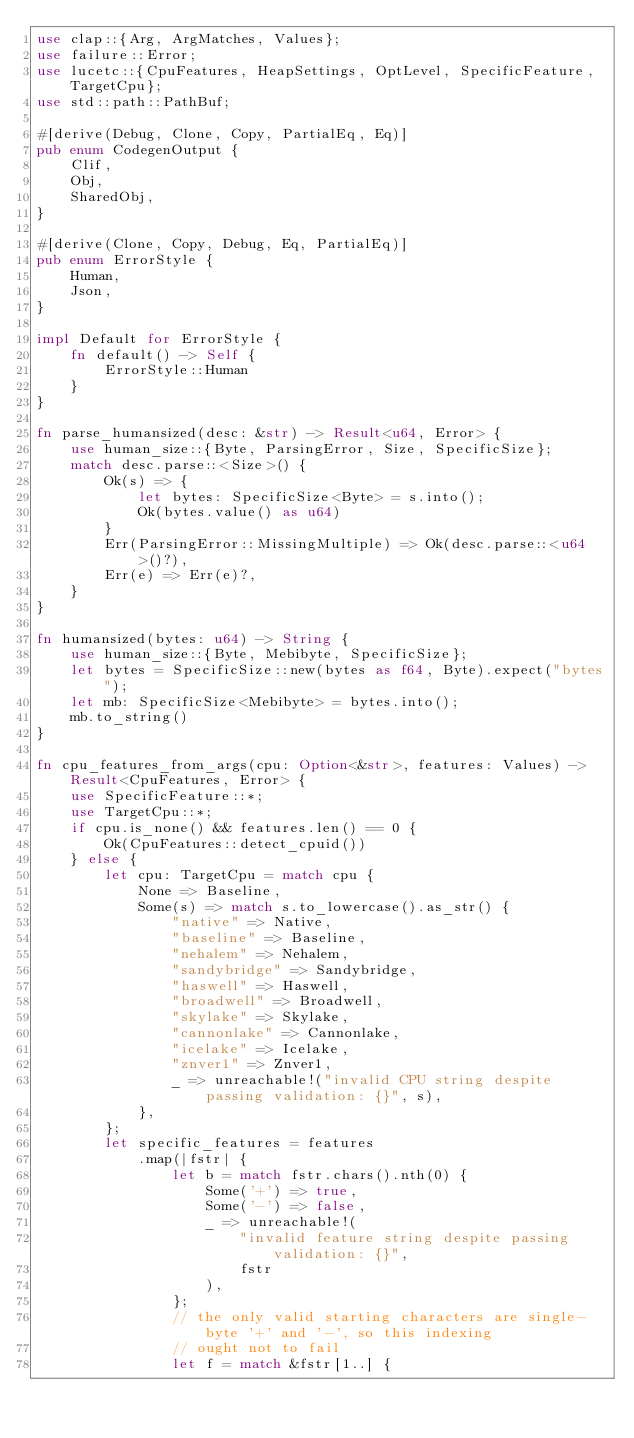Convert code to text. <code><loc_0><loc_0><loc_500><loc_500><_Rust_>use clap::{Arg, ArgMatches, Values};
use failure::Error;
use lucetc::{CpuFeatures, HeapSettings, OptLevel, SpecificFeature, TargetCpu};
use std::path::PathBuf;

#[derive(Debug, Clone, Copy, PartialEq, Eq)]
pub enum CodegenOutput {
    Clif,
    Obj,
    SharedObj,
}

#[derive(Clone, Copy, Debug, Eq, PartialEq)]
pub enum ErrorStyle {
    Human,
    Json,
}

impl Default for ErrorStyle {
    fn default() -> Self {
        ErrorStyle::Human
    }
}

fn parse_humansized(desc: &str) -> Result<u64, Error> {
    use human_size::{Byte, ParsingError, Size, SpecificSize};
    match desc.parse::<Size>() {
        Ok(s) => {
            let bytes: SpecificSize<Byte> = s.into();
            Ok(bytes.value() as u64)
        }
        Err(ParsingError::MissingMultiple) => Ok(desc.parse::<u64>()?),
        Err(e) => Err(e)?,
    }
}

fn humansized(bytes: u64) -> String {
    use human_size::{Byte, Mebibyte, SpecificSize};
    let bytes = SpecificSize::new(bytes as f64, Byte).expect("bytes");
    let mb: SpecificSize<Mebibyte> = bytes.into();
    mb.to_string()
}

fn cpu_features_from_args(cpu: Option<&str>, features: Values) -> Result<CpuFeatures, Error> {
    use SpecificFeature::*;
    use TargetCpu::*;
    if cpu.is_none() && features.len() == 0 {
        Ok(CpuFeatures::detect_cpuid())
    } else {
        let cpu: TargetCpu = match cpu {
            None => Baseline,
            Some(s) => match s.to_lowercase().as_str() {
                "native" => Native,
                "baseline" => Baseline,
                "nehalem" => Nehalem,
                "sandybridge" => Sandybridge,
                "haswell" => Haswell,
                "broadwell" => Broadwell,
                "skylake" => Skylake,
                "cannonlake" => Cannonlake,
                "icelake" => Icelake,
                "znver1" => Znver1,
                _ => unreachable!("invalid CPU string despite passing validation: {}", s),
            },
        };
        let specific_features = features
            .map(|fstr| {
                let b = match fstr.chars().nth(0) {
                    Some('+') => true,
                    Some('-') => false,
                    _ => unreachable!(
                        "invalid feature string despite passing validation: {}",
                        fstr
                    ),
                };
                // the only valid starting characters are single-byte '+' and '-', so this indexing
                // ought not to fail
                let f = match &fstr[1..] {</code> 